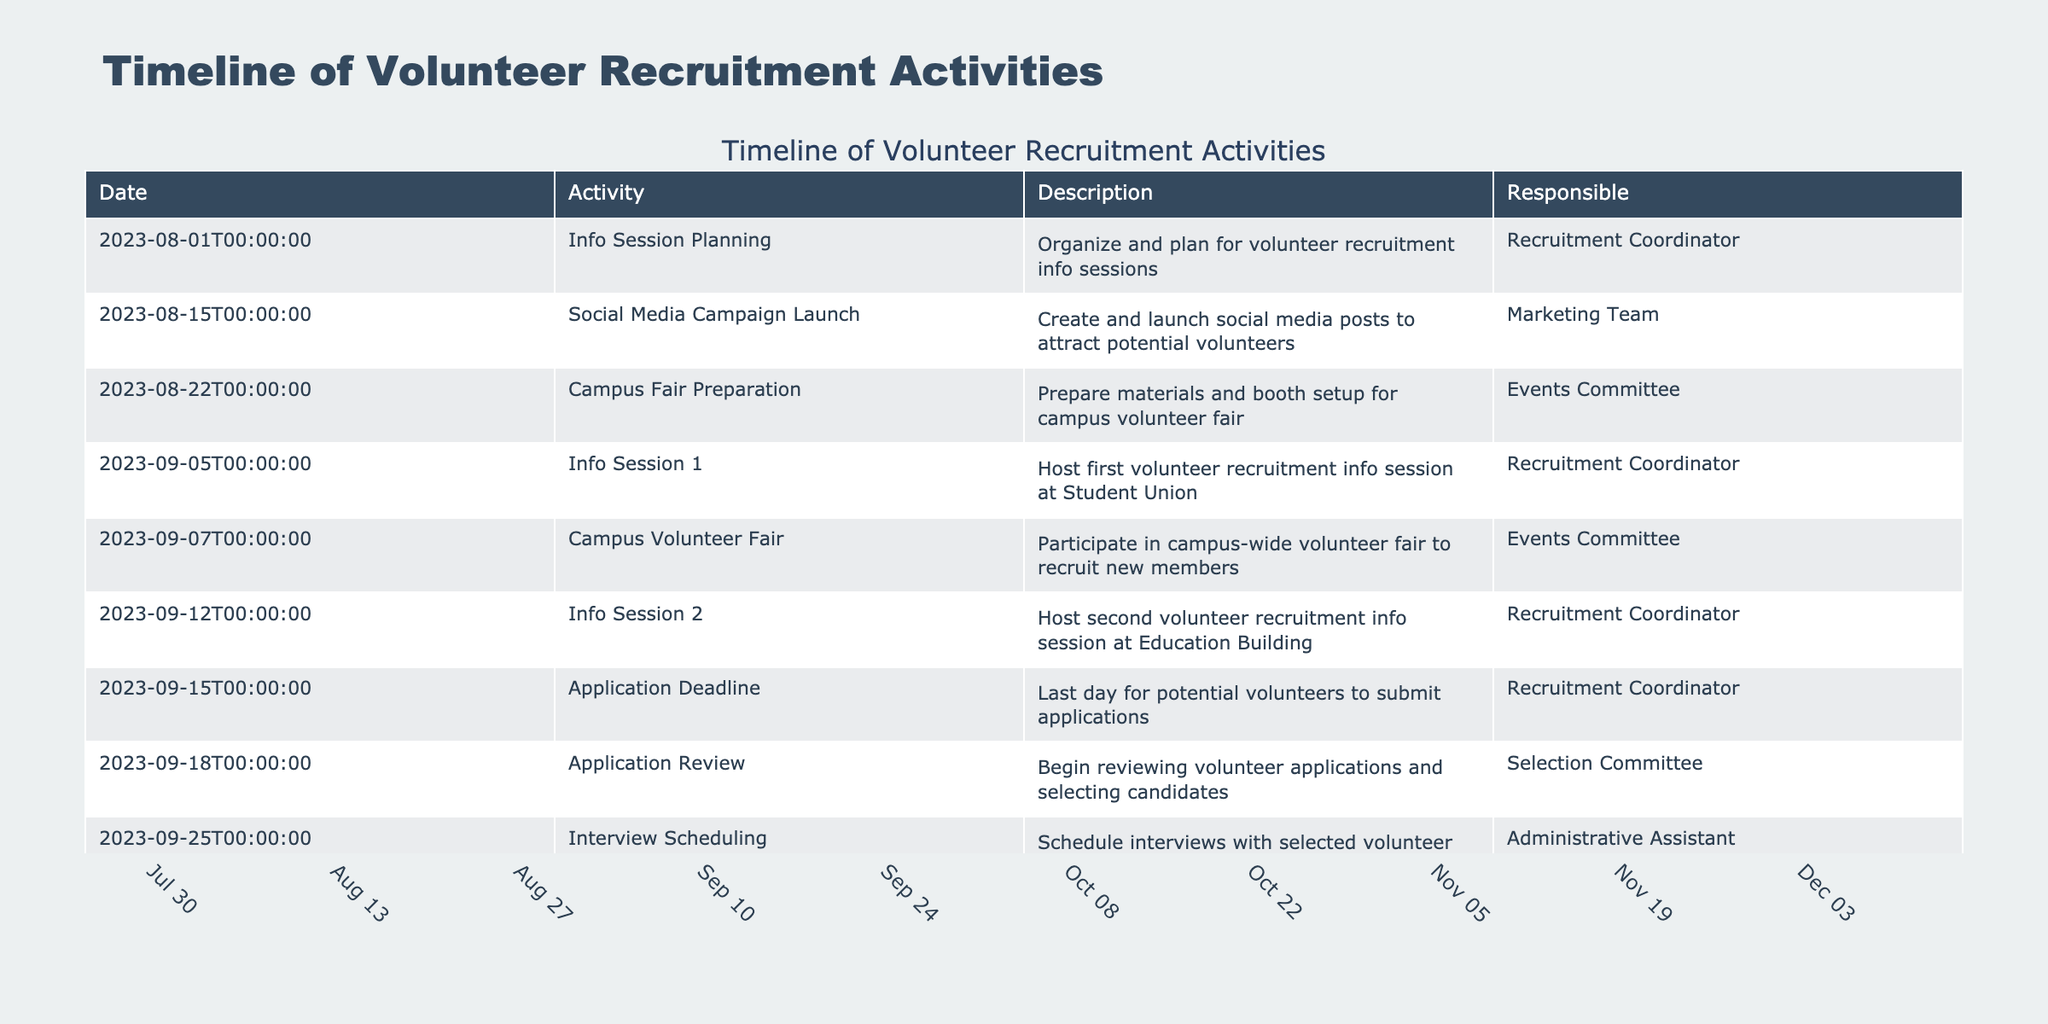What is the date of the first volunteer recruitment info session? The first info session is listed under the "Activity" column with the date "2023-09-05".
Answer: 2023-09-05 Who is responsible for hosting Info Session 2? The "Responsible" column for "Info Session 2" shows "Recruitment Coordinator".
Answer: Recruitment Coordinator How many training workshops are scheduled before the project kickoff? There are two workshops listed before the project kickoff on "2023-12-08" — "Training Workshop 1" on "2023-11-17" and "Training Workshop 2" on "2023-11-24". Thus, the total is 2.
Answer: 2 Is there a campus volunteer fair scheduled before the application deadline? The campus volunteer fair on "2023-09-07" is scheduled before the application deadline on "2023-09-15". Therefore, the answer is yes.
Answer: Yes When does the interview process begin and end? The interviews start on "2023-10-02" and end on "2023-10-13". Therefore, the range is from October 2 to October 13.
Answer: October 2 to October 13 What is the total number of activities listed in the timeline? There are 20 distinct activities documented in the table from start to finish.
Answer: 20 Which committee is involved in the planning of the volunteer orientation session? The "Training Coordinator" is responsible for planning the volunteer orientation session which takes place on "2023-11-03".
Answer: Training Coordinator What activities are scheduled on September 12 and September 18? On September 12, "Info Session 2" is scheduled, and on September 18, "Application Review" takes place.
Answer: Info Session 2 and Application Review Which activity comes directly after acceptance notifications are sent? The activity that follows "Acceptance Notifications" on "2023-10-20" is "Orientation Planning" scheduled for "2023-10-27".
Answer: Orientation Planning 